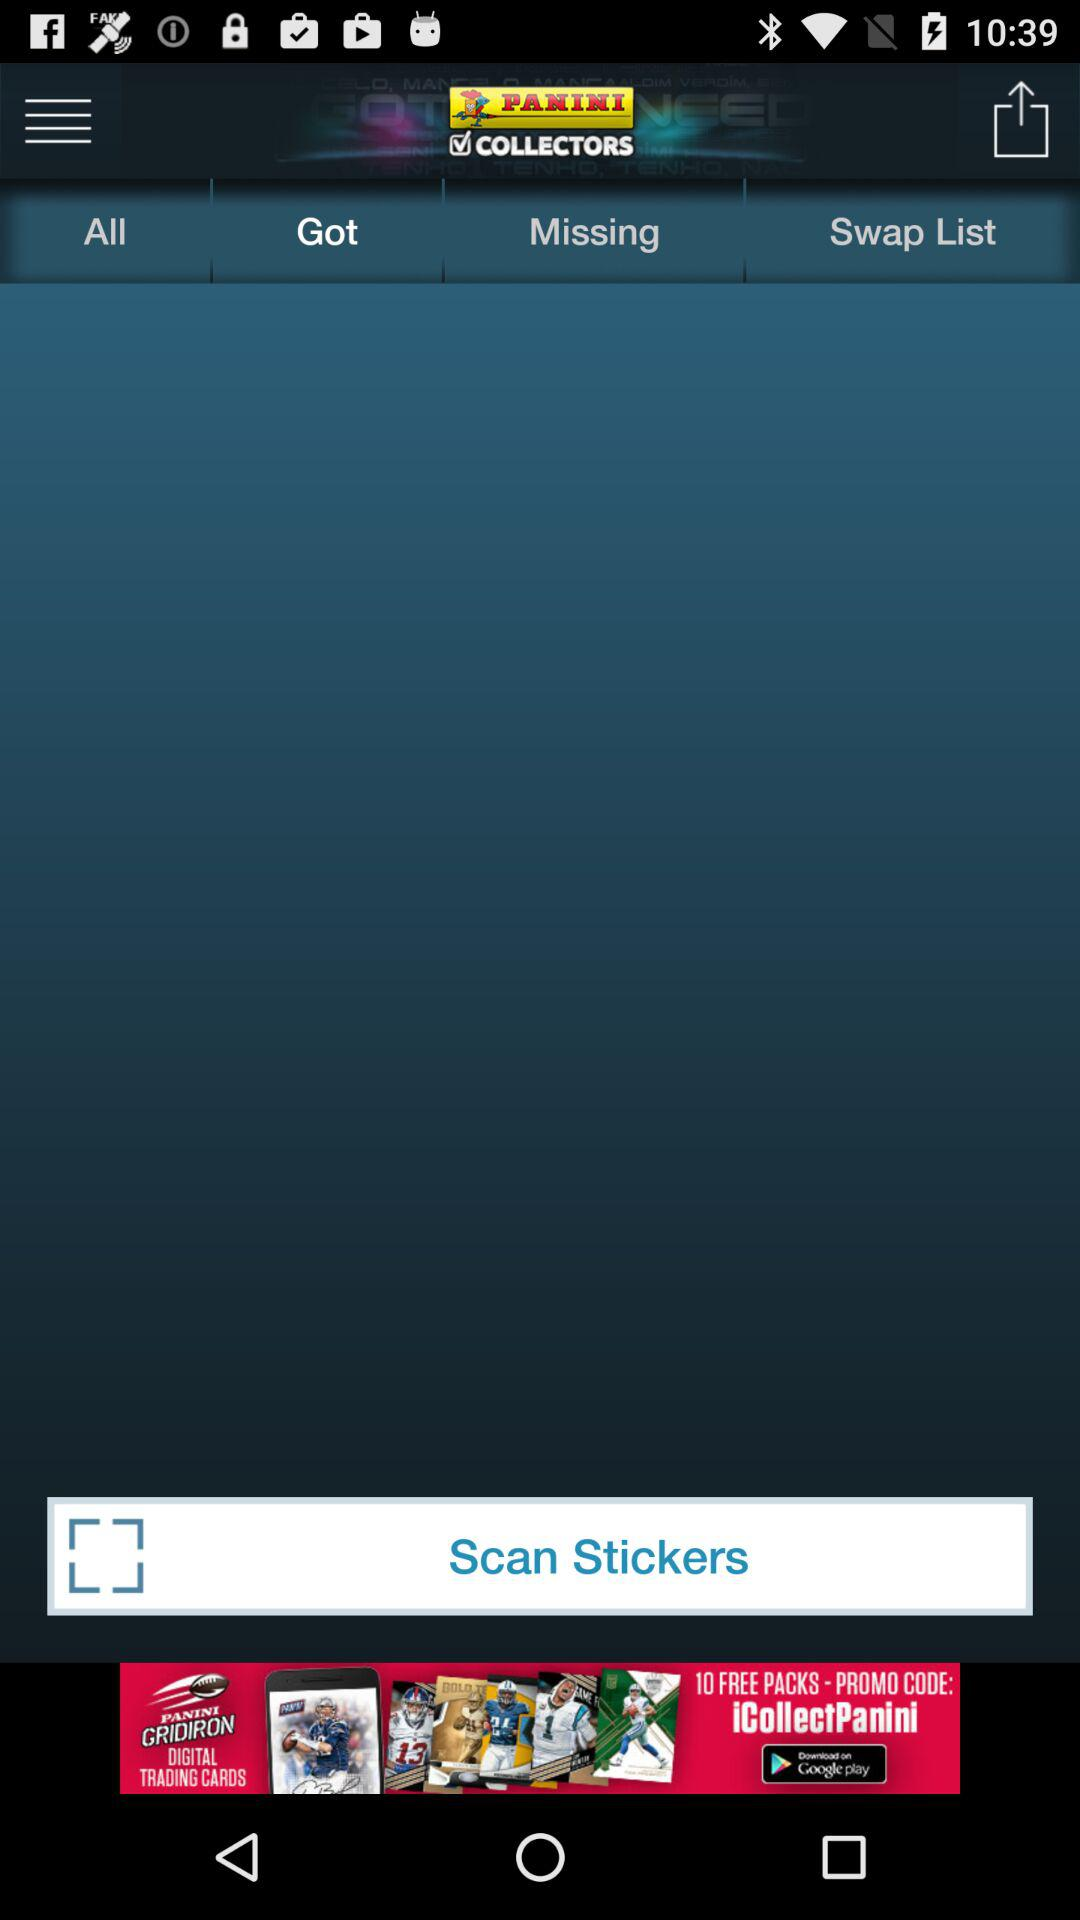What is the application name? The application name is Panini Collectors. 